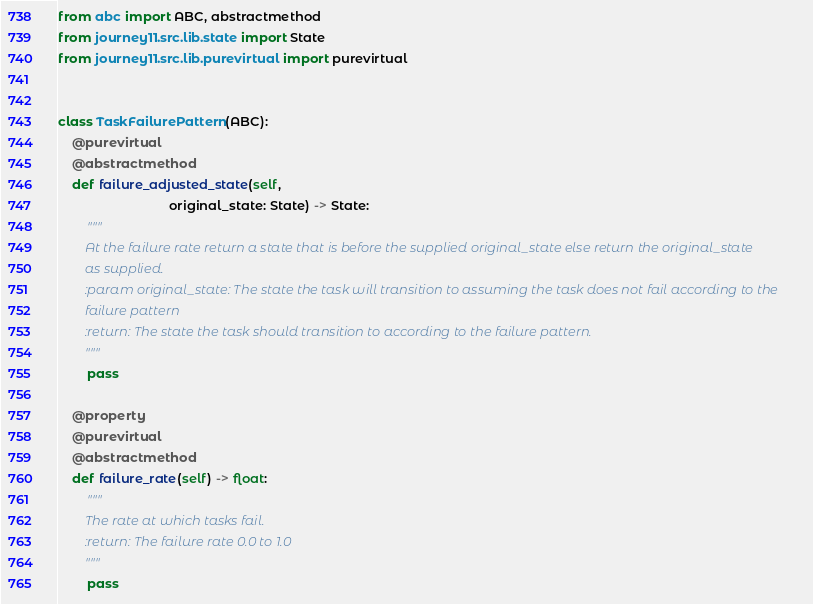Convert code to text. <code><loc_0><loc_0><loc_500><loc_500><_Python_>from abc import ABC, abstractmethod
from journey11.src.lib.state import State
from journey11.src.lib.purevirtual import purevirtual


class TaskFailurePattern(ABC):
    @purevirtual
    @abstractmethod
    def failure_adjusted_state(self,
                               original_state: State) -> State:
        """
        At the failure rate return a state that is before the supplied original_state else return the original_state
        as supplied.
        :param original_state: The state the task will transition to assuming the task does not fail according to the
        failure pattern
        :return: The state the task should transition to according to the failure pattern.
        """
        pass

    @property
    @purevirtual
    @abstractmethod
    def failure_rate(self) -> float:
        """
        The rate at which tasks fail.
        :return: The failure rate 0.0 to 1.0
        """
        pass
</code> 